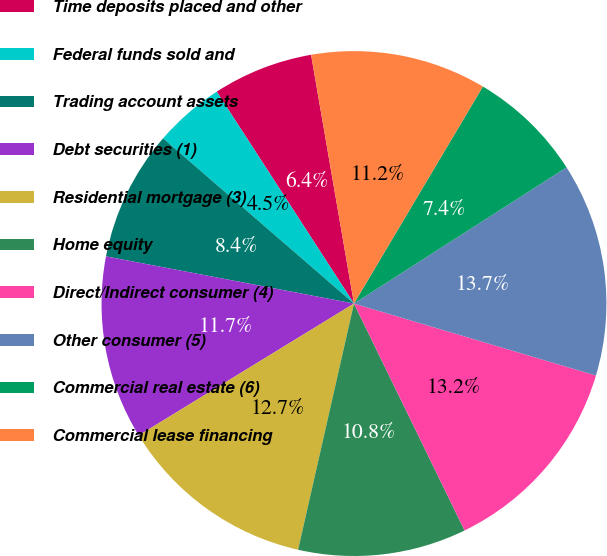Convert chart. <chart><loc_0><loc_0><loc_500><loc_500><pie_chart><fcel>Time deposits placed and other<fcel>Federal funds sold and<fcel>Trading account assets<fcel>Debt securities (1)<fcel>Residential mortgage (3)<fcel>Home equity<fcel>Direct/Indirect consumer (4)<fcel>Other consumer (5)<fcel>Commercial real estate (6)<fcel>Commercial lease financing<nl><fcel>6.43%<fcel>4.5%<fcel>8.36%<fcel>11.74%<fcel>12.7%<fcel>10.77%<fcel>13.18%<fcel>13.67%<fcel>7.4%<fcel>11.25%<nl></chart> 